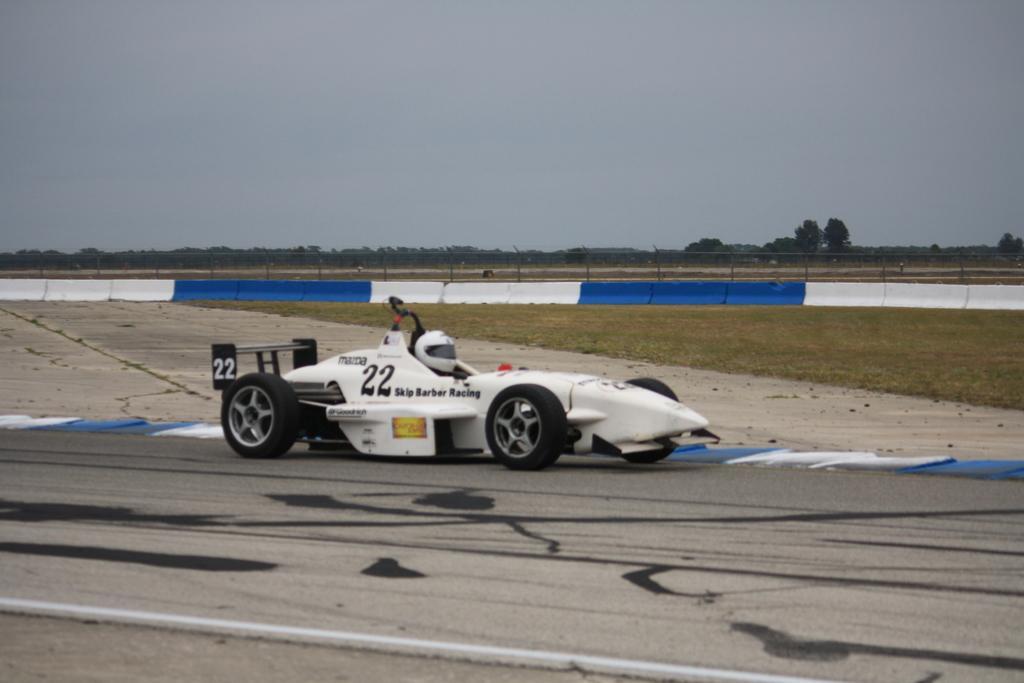How would you summarize this image in a sentence or two? In this picture I can see the road in front, on which there is a sports car and I see something is written on it. In the middle of this picture I see the grass and the fencing. In the background I see the trees and the sky. 